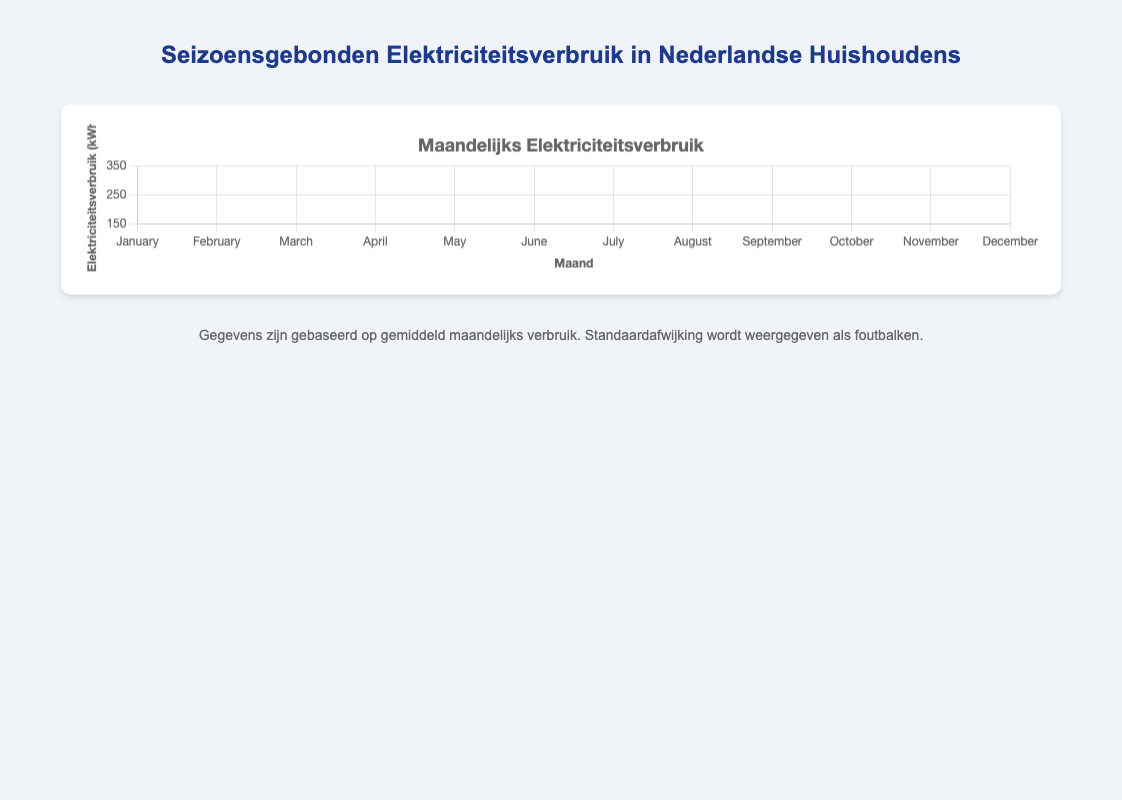Which month has the highest average electricity consumption? The highest average consumption corresponds to January with 320 kWh, which is the peak value observed on the curve.
Answer: January What is the difference in average consumption between the months with the highest and the lowest average electricity consumption? The highest average is in January (320 kWh) and the lowest is in July (190 kWh). The difference is calculated as 320 - 190 = 130 kWh.
Answer: 130 kWh During which month is the electricity consumption the most stable, based on the standard deviation? Stable consumption can be identified by the smallest standard deviation. July has the smallest standard deviation of 7 kWh.
Answer: July Which month shows an increase in average consumption compared to the previous month and by how much? From July to August, the average consumption increases by 5 kWh (from 190 kWh to 195 kWh). Mathematically, 195 - 190 = 5 kWh.
Answer: August, 5 kWh Between which months does the sharpest decrease in average electricity consumption occur? The steepest decline occurs between January (320 kWh) and February (310 kWh), where the difference is 10 kWh. Although other months have decreases, they are less sharp.
Answer: January to February How does the average electricity consumption in December compare to the average in January? January has 320 kWh, and December has 300 kWh. January’s consumption is higher than December by 320 - 300 = 20 kWh.
Answer: January is higher by 20 kWh Which months exhibit the same trend in terms of change in average electricity consumption (either all increasing or all decreasing)? The months from April to July show a continuous decrease in consumption from 250 kWh in April to 190 kWh in July, a steady downward trend.
Answer: April to July What is the overall pattern in electricity consumption from January to December? The pattern exhibits higher consumption in the winter months (January to March and November to December) and lower consumption in the summer months (June to August), where the curve dips significantly.
Answer: Higher in winter, lower in summer Which two consecutive months have the closest average electricity consumption values? July and August have very close average consumption values, 190 kWh in July and 195 kWh in August, differing by only 5 kWh.
Answer: July and August What is the range of the average electricity consumption values from the data? The range is determined by subtracting the smallest value (July, 190 kWh) from the largest value (January, 320 kWh). Thus, the range is 320 - 190 = 130 kWh.
Answer: 130 kWh 